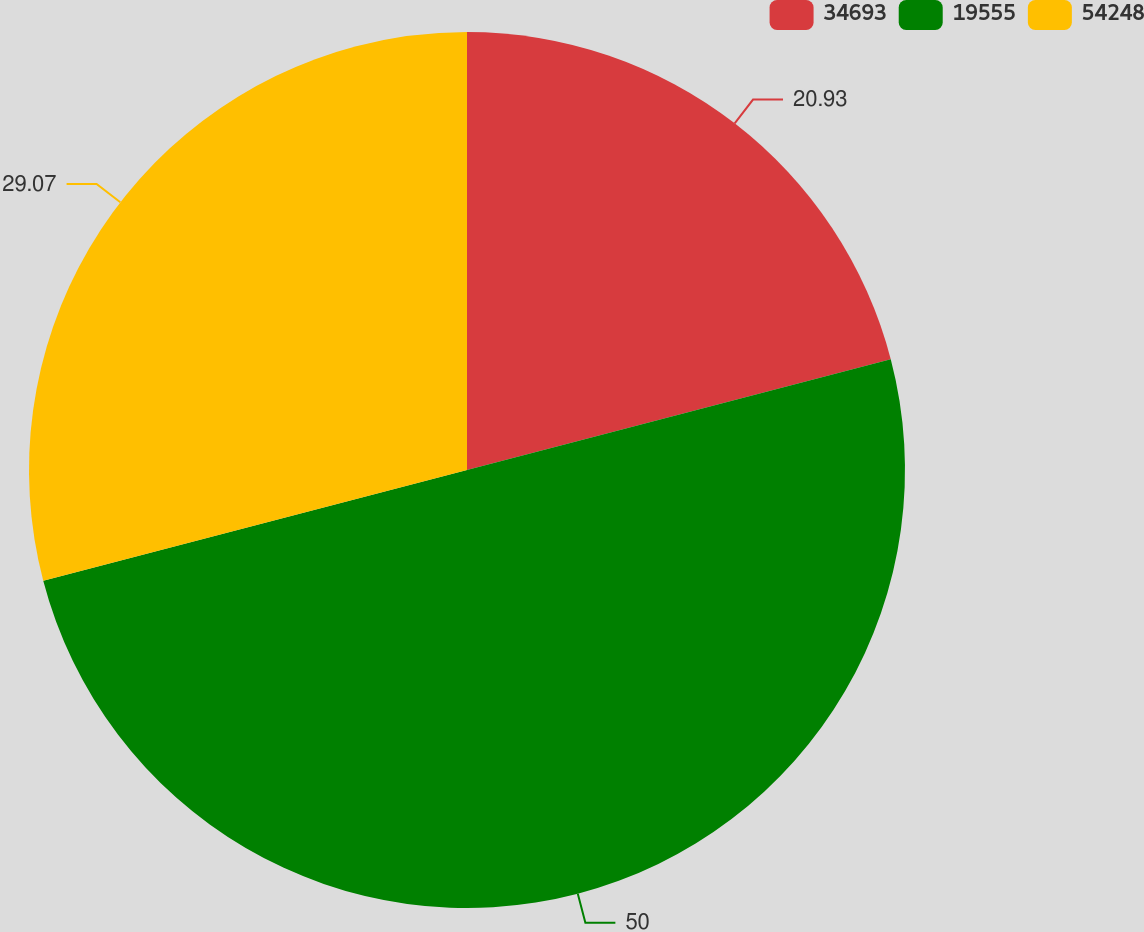Convert chart to OTSL. <chart><loc_0><loc_0><loc_500><loc_500><pie_chart><fcel>34693<fcel>19555<fcel>54248<nl><fcel>20.93%<fcel>50.0%<fcel>29.07%<nl></chart> 